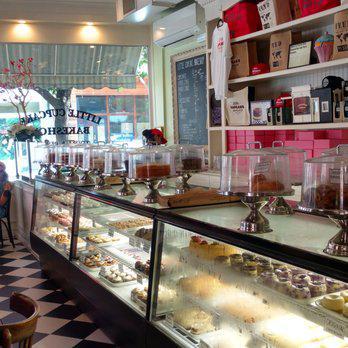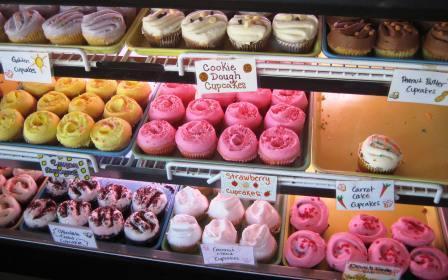The first image is the image on the left, the second image is the image on the right. Given the left and right images, does the statement "One image shows a line of desserts displayed under glass on silver pedestals atop a counter, and the other image shows a glass display front that includes pink, yellow, white and brown frosted cupcakes." hold true? Answer yes or no. Yes. The first image is the image on the left, the second image is the image on the right. Assess this claim about the two images: "There are lemon pastries on the middle shelf.". Correct or not? Answer yes or no. Yes. 